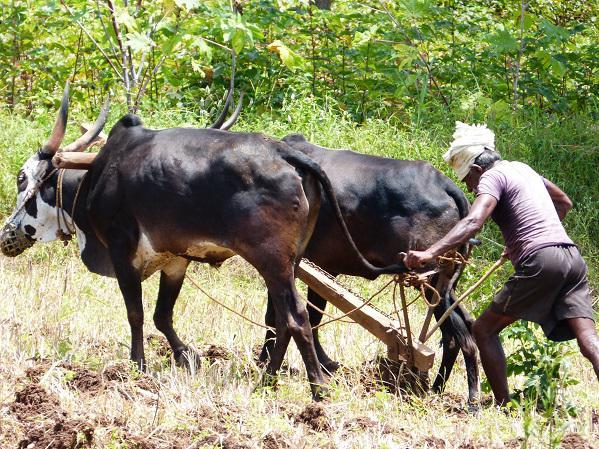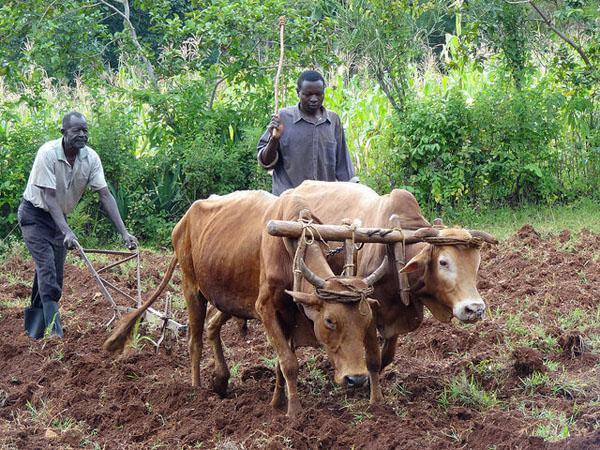The first image is the image on the left, the second image is the image on the right. For the images shown, is this caption "In one of the images, water buffalos are standing in muddy water." true? Answer yes or no. No. The first image is the image on the left, the second image is the image on the right. Considering the images on both sides, is "Each image shows at least one man interacting with a team of two hitched oxen, and one image shows a man holding a stick behind oxen." valid? Answer yes or no. Yes. 